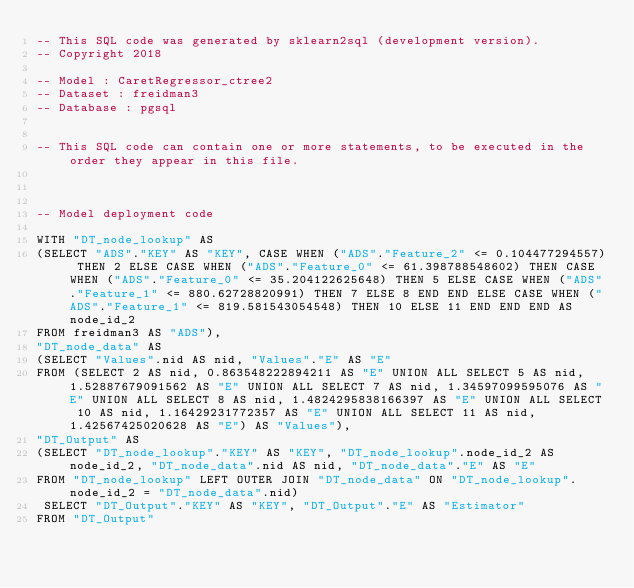<code> <loc_0><loc_0><loc_500><loc_500><_SQL_>-- This SQL code was generated by sklearn2sql (development version).
-- Copyright 2018

-- Model : CaretRegressor_ctree2
-- Dataset : freidman3
-- Database : pgsql


-- This SQL code can contain one or more statements, to be executed in the order they appear in this file.



-- Model deployment code

WITH "DT_node_lookup" AS 
(SELECT "ADS"."KEY" AS "KEY", CASE WHEN ("ADS"."Feature_2" <= 0.104477294557) THEN 2 ELSE CASE WHEN ("ADS"."Feature_0" <= 61.398788548602) THEN CASE WHEN ("ADS"."Feature_0" <= 35.204122625648) THEN 5 ELSE CASE WHEN ("ADS"."Feature_1" <= 880.62728820991) THEN 7 ELSE 8 END END ELSE CASE WHEN ("ADS"."Feature_1" <= 819.581543054548) THEN 10 ELSE 11 END END END AS node_id_2 
FROM freidman3 AS "ADS"), 
"DT_node_data" AS 
(SELECT "Values".nid AS nid, "Values"."E" AS "E" 
FROM (SELECT 2 AS nid, 0.863548222894211 AS "E" UNION ALL SELECT 5 AS nid, 1.52887679091562 AS "E" UNION ALL SELECT 7 AS nid, 1.34597099595076 AS "E" UNION ALL SELECT 8 AS nid, 1.4824295838166397 AS "E" UNION ALL SELECT 10 AS nid, 1.16429231772357 AS "E" UNION ALL SELECT 11 AS nid, 1.42567425020628 AS "E") AS "Values"), 
"DT_Output" AS 
(SELECT "DT_node_lookup"."KEY" AS "KEY", "DT_node_lookup".node_id_2 AS node_id_2, "DT_node_data".nid AS nid, "DT_node_data"."E" AS "E" 
FROM "DT_node_lookup" LEFT OUTER JOIN "DT_node_data" ON "DT_node_lookup".node_id_2 = "DT_node_data".nid)
 SELECT "DT_Output"."KEY" AS "KEY", "DT_Output"."E" AS "Estimator" 
FROM "DT_Output"</code> 